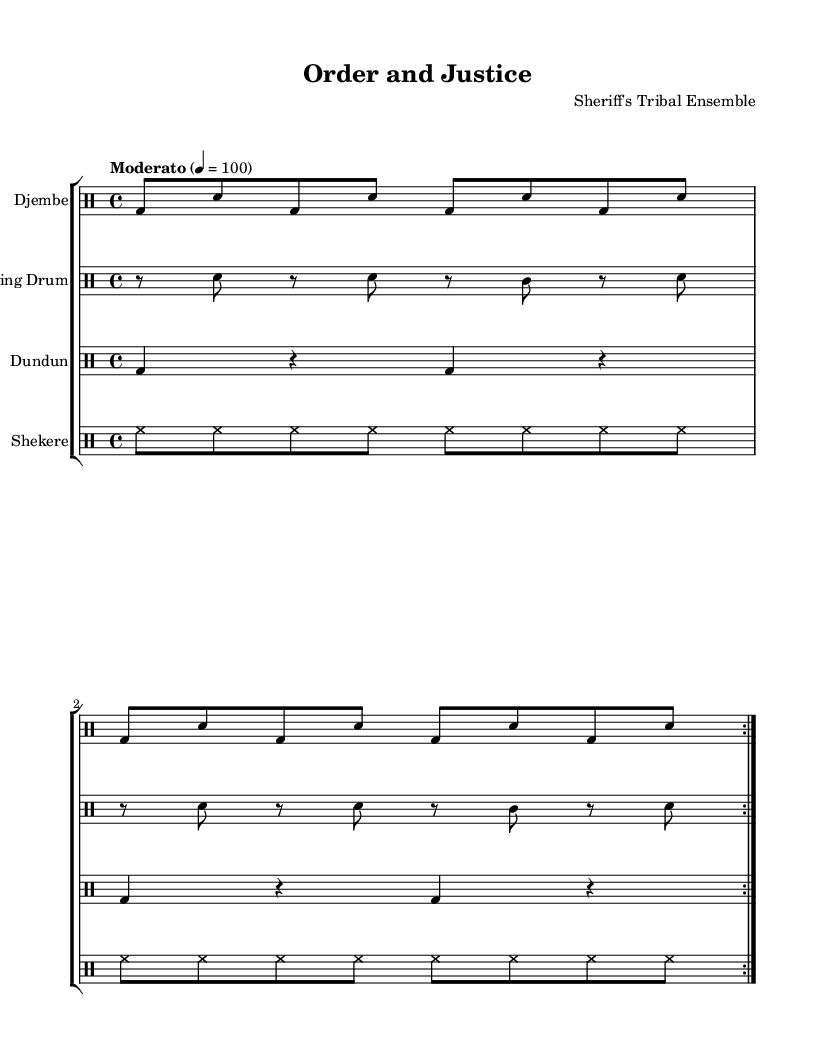What is the time signature of this music? The time signature is indicated at the beginning of the score, where it shows 4/4. This means there are four beats in each measure and the quarter note gets one beat.
Answer: 4/4 What is the key signature of this music? The key signature shows no sharps or flats, which indicates that the music is in C major. This can be deduced from the absence of any accidental notes indicated.
Answer: C major What is the tempo of the piece? The tempo of the piece is indicated as "Moderato" with a marking of 4 = 100, which tells the performer to play at a moderate speed of 100 beats per minute.
Answer: Moderato How many times is the djembe rhythm repeated? The djembe rhythm is repeated two times as indicated by the "volta" repeat sign in the score, which shows that the section should be played twice.
Answer: 2 What types of drums are represented in this music? The score includes various types of drums: Djembe, Talking Drum, Dundun, and Shekere. Each is labeled at the beginning of its respective staff, indicating the specific instrument being used.
Answer: Djembe, Talking Drum, Dundun, Shekere What is the rhythmic pattern of the dundun? The rhythmic pattern of the dundun consists of a sequence of bass drum beats and rests, specifically two beats followed by a rest in a four-quarter time signature. This can be seen in its staff representation.
Answer: bass drum beats and rests 